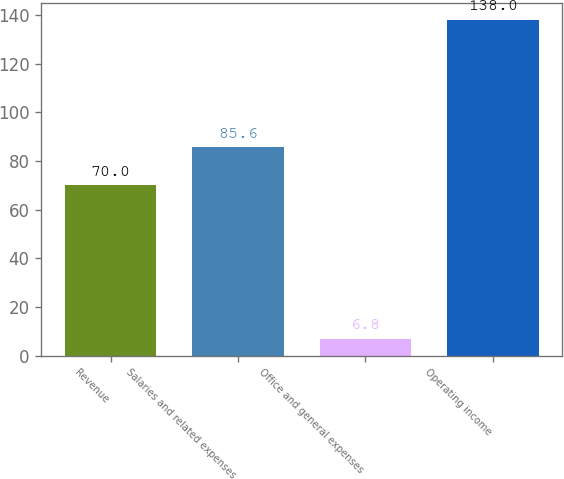Convert chart. <chart><loc_0><loc_0><loc_500><loc_500><bar_chart><fcel>Revenue<fcel>Salaries and related expenses<fcel>Office and general expenses<fcel>Operating income<nl><fcel>70<fcel>85.6<fcel>6.8<fcel>138<nl></chart> 